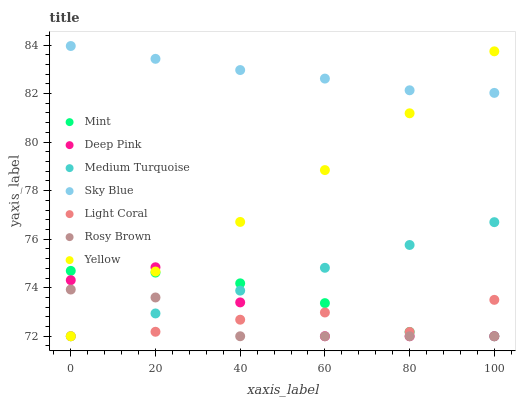Does Rosy Brown have the minimum area under the curve?
Answer yes or no. Yes. Does Sky Blue have the maximum area under the curve?
Answer yes or no. Yes. Does Yellow have the minimum area under the curve?
Answer yes or no. No. Does Yellow have the maximum area under the curve?
Answer yes or no. No. Is Medium Turquoise the smoothest?
Answer yes or no. Yes. Is Light Coral the roughest?
Answer yes or no. Yes. Is Rosy Brown the smoothest?
Answer yes or no. No. Is Rosy Brown the roughest?
Answer yes or no. No. Does Deep Pink have the lowest value?
Answer yes or no. Yes. Does Sky Blue have the lowest value?
Answer yes or no. No. Does Sky Blue have the highest value?
Answer yes or no. Yes. Does Rosy Brown have the highest value?
Answer yes or no. No. Is Rosy Brown less than Sky Blue?
Answer yes or no. Yes. Is Sky Blue greater than Medium Turquoise?
Answer yes or no. Yes. Does Light Coral intersect Rosy Brown?
Answer yes or no. Yes. Is Light Coral less than Rosy Brown?
Answer yes or no. No. Is Light Coral greater than Rosy Brown?
Answer yes or no. No. Does Rosy Brown intersect Sky Blue?
Answer yes or no. No. 